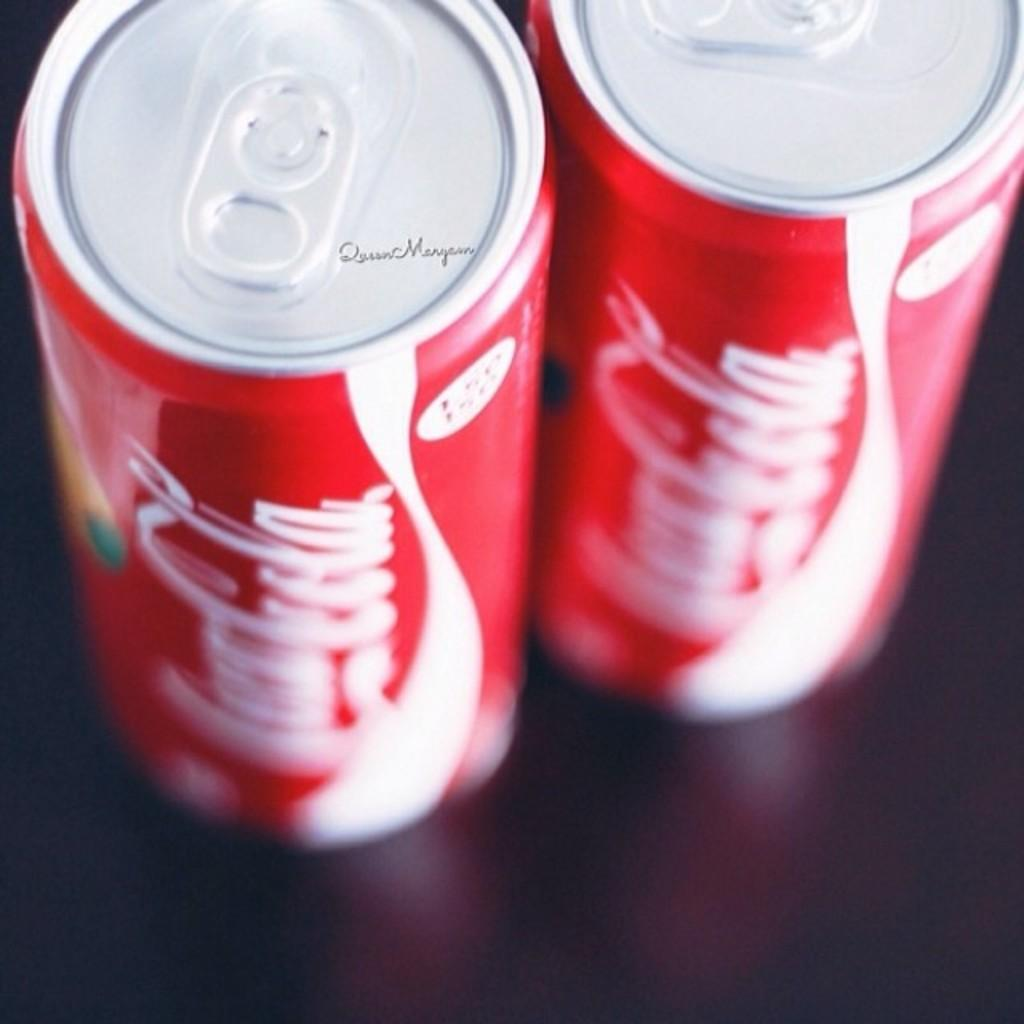<image>
Create a compact narrative representing the image presented. Two cans of Coca Cola, one of which says Queen Maryann on the top of it. 